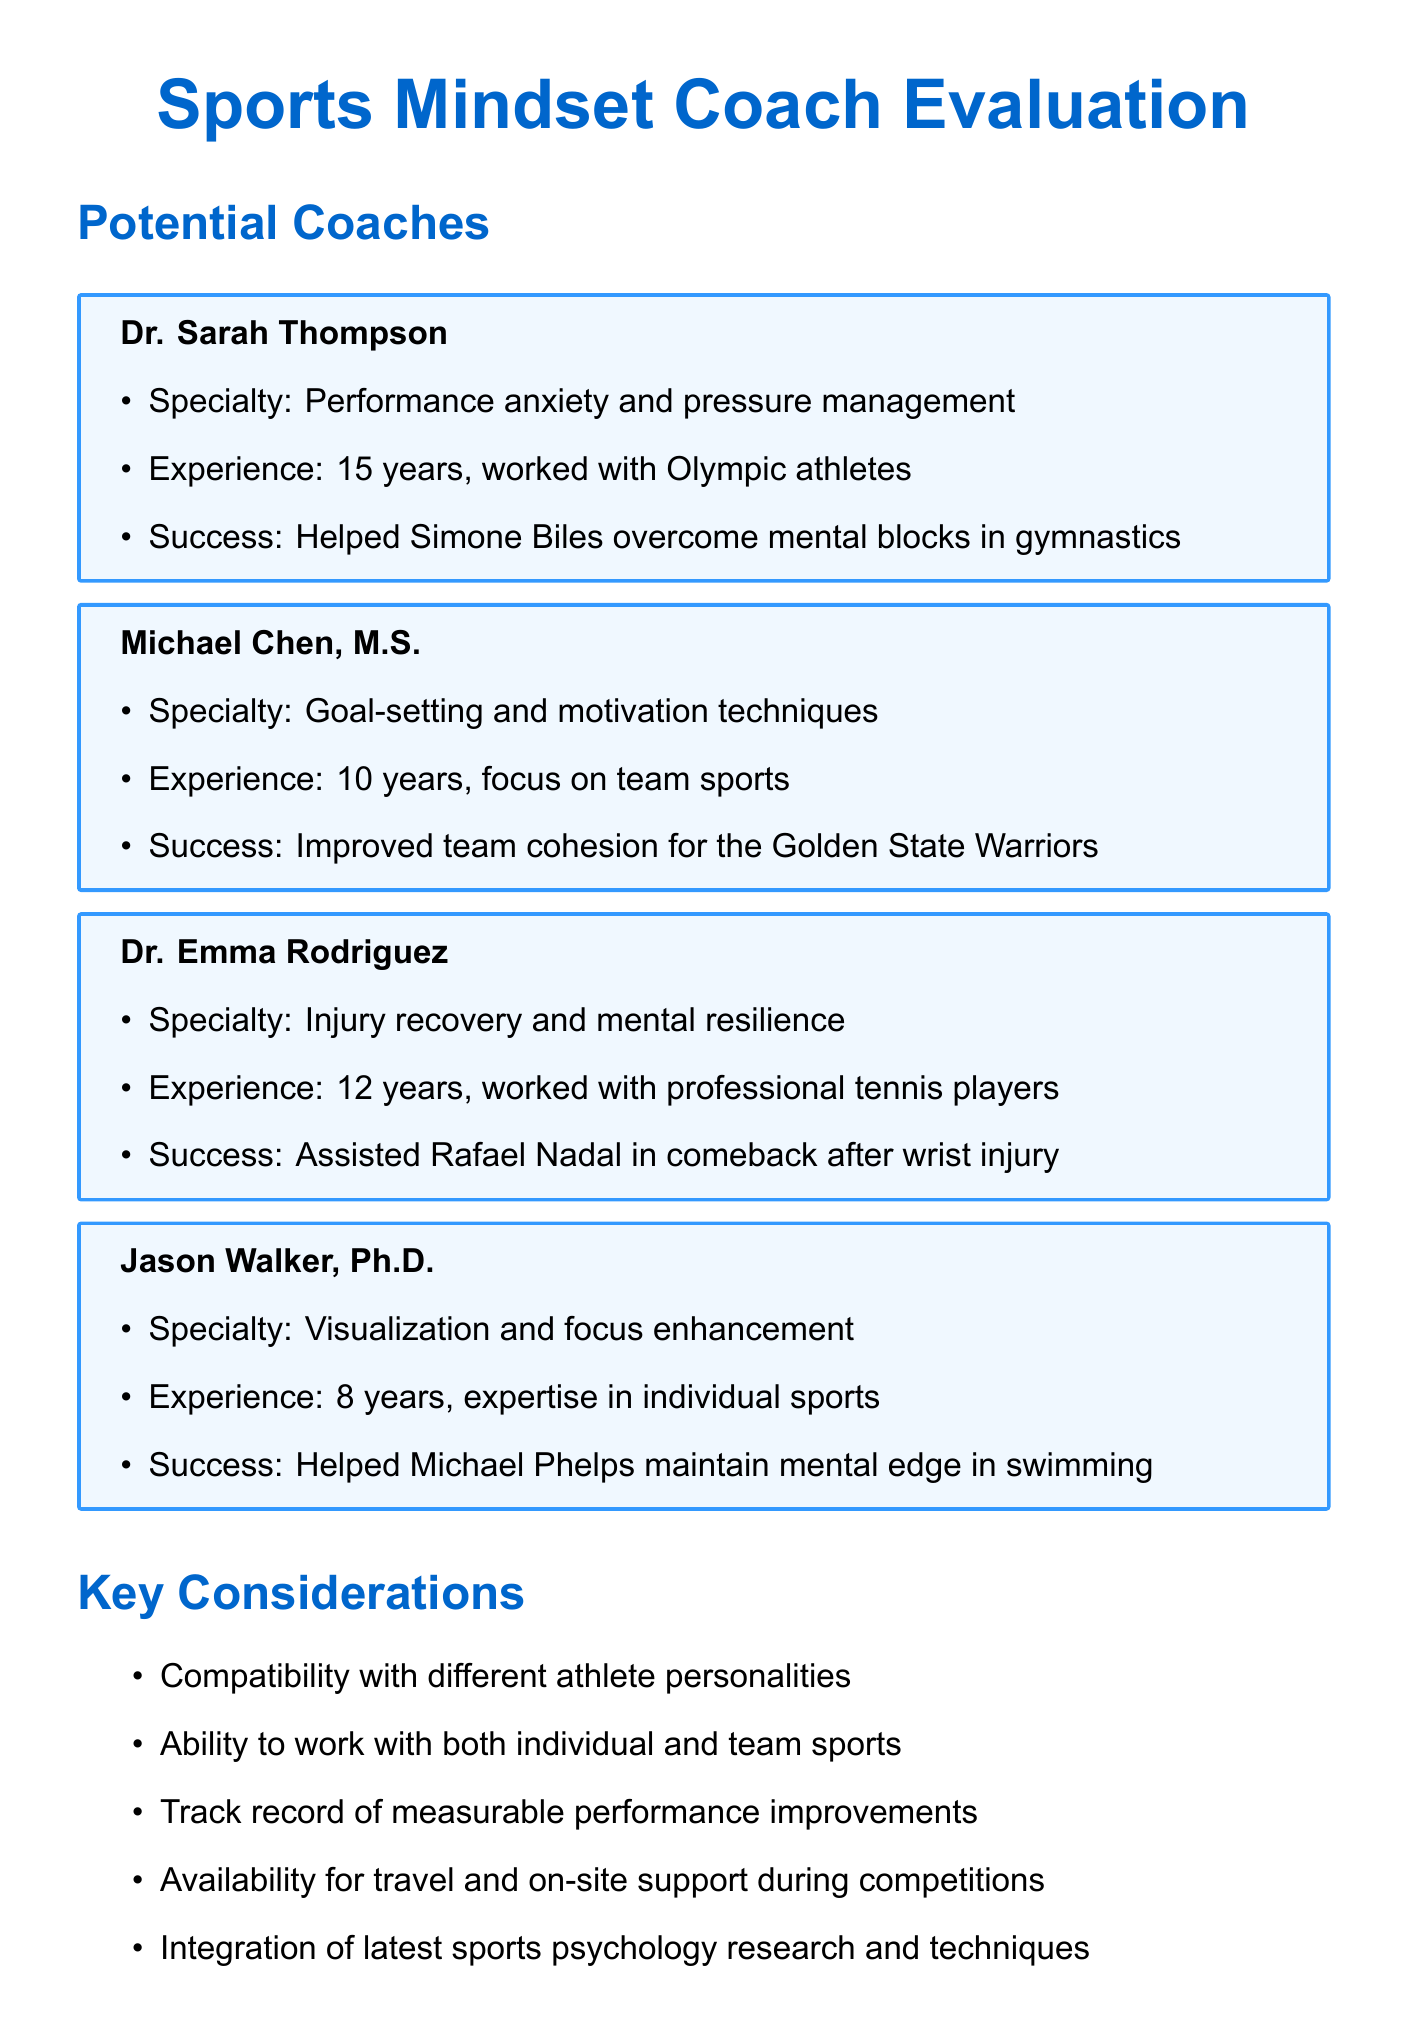What is the specialty of Dr. Sarah Thompson? Dr. Sarah Thompson specializes in performance anxiety and pressure management, as stated in her profile.
Answer: Performance anxiety and pressure management How many years of experience does Michael Chen have? Michael Chen has 10 years of experience, which is directly mentioned in his information.
Answer: 10 years Who did Dr. Emma Rodriguez assist with injury recovery? The document states that Dr. Emma Rodriguez assisted Rafael Nadal in his comeback after a wrist injury.
Answer: Rafael Nadal What is Jason Walker's area of expertise? Jason Walker's area of expertise is in visualization and focus enhancement, as mentioned in the potential coaches section.
Answer: Visualization and focus enhancement What kind of sports has Michael Chen primarily focused on? Michael Chen primarily focuses on team sports, which is explicitly indicated in his description.
Answer: Team sports How many client success stories are listed for the coaches? There are four client success stories listed, one for each coach mentioned at the beginning of the document.
Answer: Four Which coach helped Simone Biles? The document specifies that Dr. Sarah Thompson helped Simone Biles overcome mental blocks in gymnastics.
Answer: Dr. Sarah Thompson What should be considered regarding a coach's compatibility? The document emphasizes the importance of compatibility with different athlete personalities as a key consideration.
Answer: Compatibility with different athlete personalities What is one evaluation criterion mentioned for the coaches? One evaluation criterion mentioned is client testimonials and references, as listed under evaluation criteria.
Answer: Client testimonials and references 